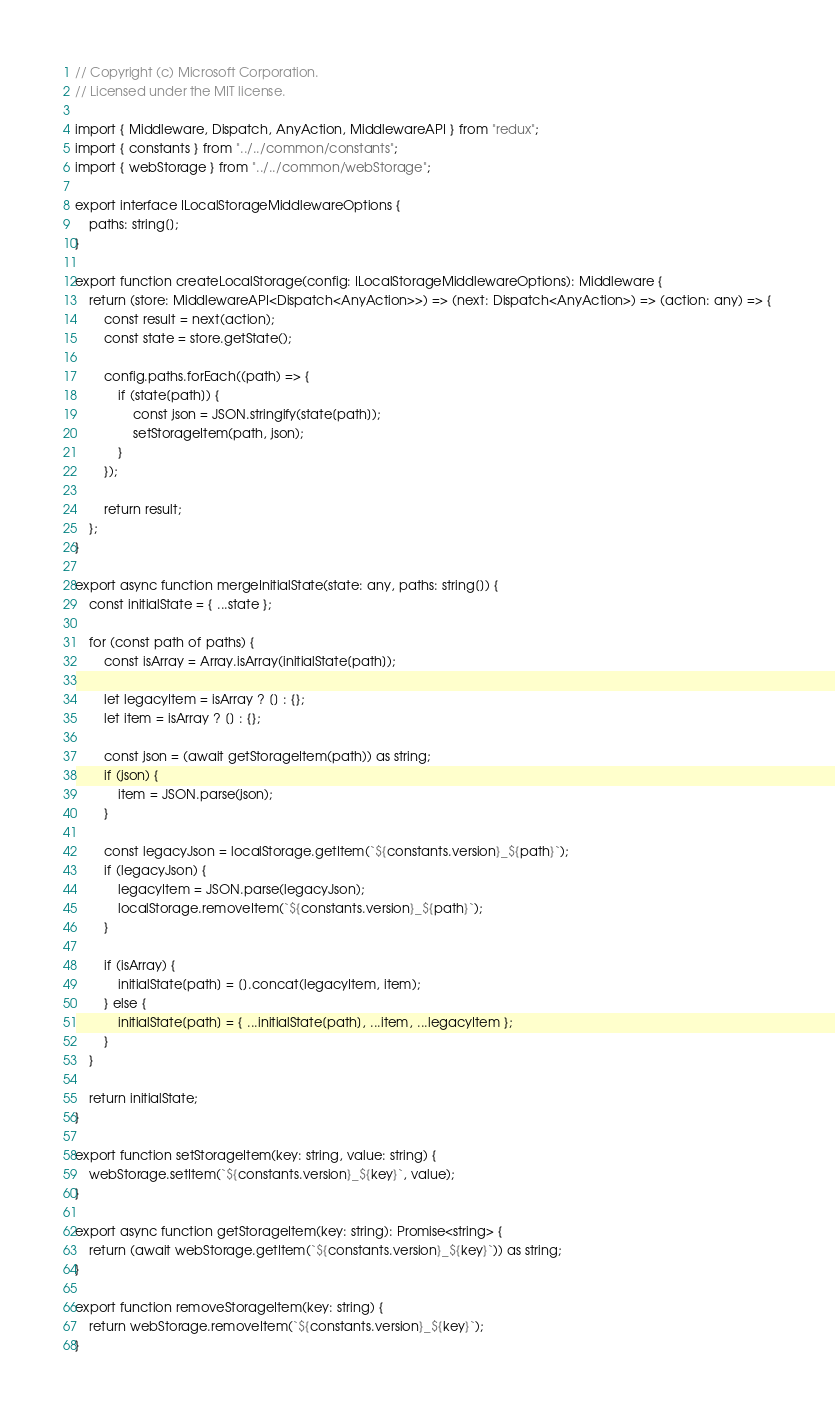<code> <loc_0><loc_0><loc_500><loc_500><_TypeScript_>// Copyright (c) Microsoft Corporation.
// Licensed under the MIT license.

import { Middleware, Dispatch, AnyAction, MiddlewareAPI } from "redux";
import { constants } from "../../common/constants";
import { webStorage } from "../../common/webStorage";

export interface ILocalStorageMiddlewareOptions {
    paths: string[];
}

export function createLocalStorage(config: ILocalStorageMiddlewareOptions): Middleware {
    return (store: MiddlewareAPI<Dispatch<AnyAction>>) => (next: Dispatch<AnyAction>) => (action: any) => {
        const result = next(action);
        const state = store.getState();

        config.paths.forEach((path) => {
            if (state[path]) {
                const json = JSON.stringify(state[path]);
                setStorageItem(path, json);
            }
        });

        return result;
    };
}

export async function mergeInitialState(state: any, paths: string[]) {
    const initialState = { ...state };

    for (const path of paths) {
        const isArray = Array.isArray(initialState[path]);

        let legacyItem = isArray ? [] : {};
        let item = isArray ? [] : {};

        const json = (await getStorageItem(path)) as string;
        if (json) {
            item = JSON.parse(json);
        }

        const legacyJson = localStorage.getItem(`${constants.version}_${path}`);
        if (legacyJson) {
            legacyItem = JSON.parse(legacyJson);
            localStorage.removeItem(`${constants.version}_${path}`);
        }

        if (isArray) {
            initialState[path] = [].concat(legacyItem, item);
        } else {
            initialState[path] = { ...initialState[path], ...item, ...legacyItem };
        }
    }

    return initialState;
}

export function setStorageItem(key: string, value: string) {
    webStorage.setItem(`${constants.version}_${key}`, value);
}

export async function getStorageItem(key: string): Promise<string> {
    return (await webStorage.getItem(`${constants.version}_${key}`)) as string;
}

export function removeStorageItem(key: string) {
    return webStorage.removeItem(`${constants.version}_${key}`);
}
</code> 